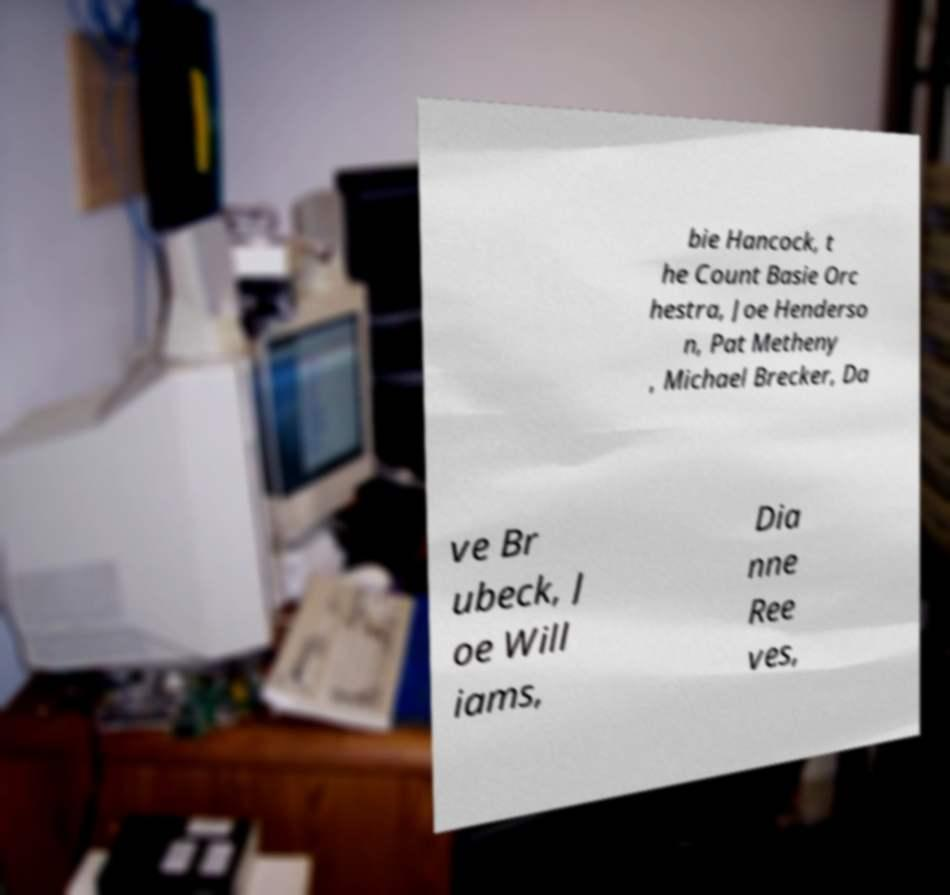Could you assist in decoding the text presented in this image and type it out clearly? bie Hancock, t he Count Basie Orc hestra, Joe Henderso n, Pat Metheny , Michael Brecker, Da ve Br ubeck, J oe Will iams, Dia nne Ree ves, 